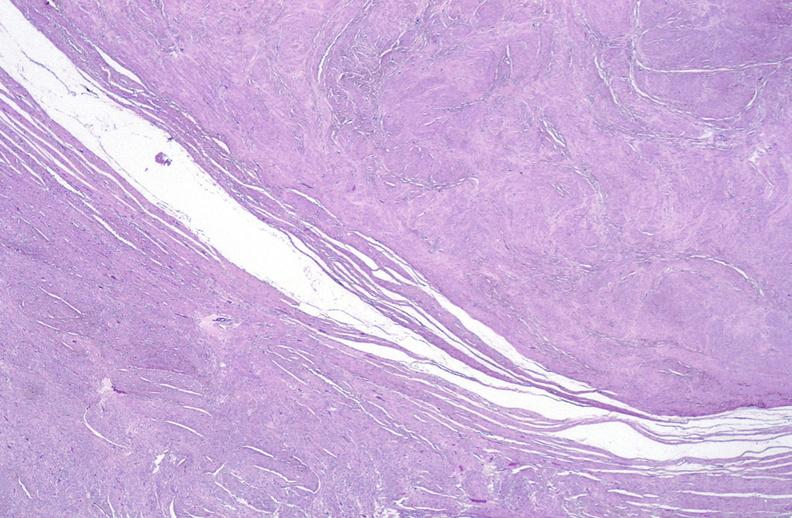does atrophy secondary to pituitectomy show leiomyoma, uterus?
Answer the question using a single word or phrase. No 